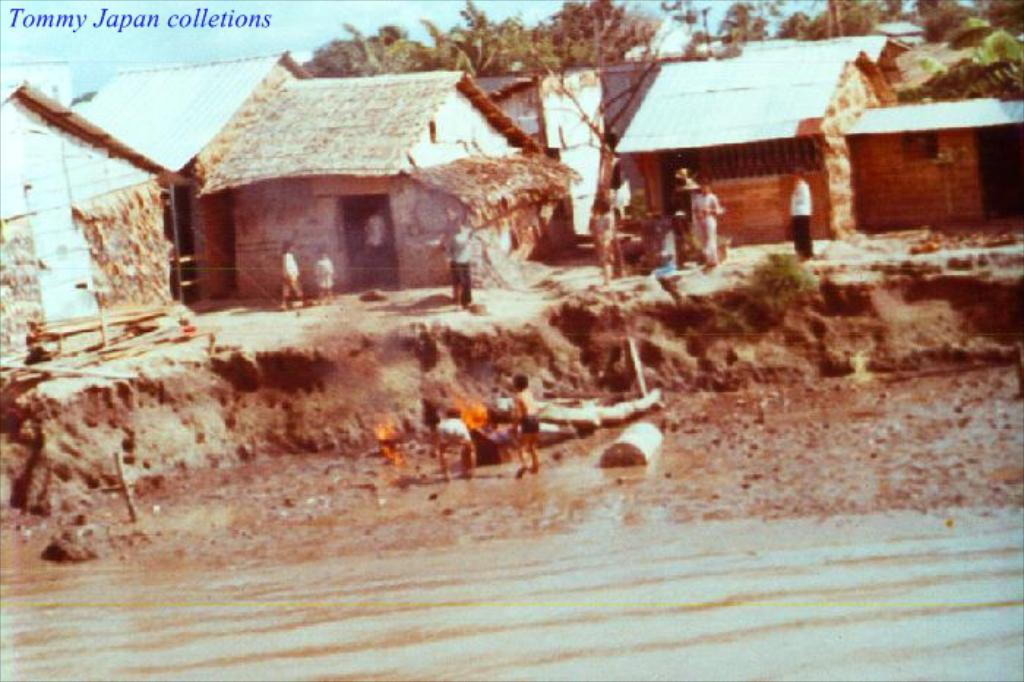What is present at the bottom of the image? There is water at the bottom side of the image. What can be seen in the background of the image? There are huts and trees in the background of the image. Where are the people located in the image? The people are in the center of the image. What type of cracker is being used to build the huts in the image? There is no cracker present in the image, and the huts are not being built. What kind of wood is used to construct the trees in the image? The image does not provide information about the type of wood used to construct the trees, as it is a photograph of real trees. 